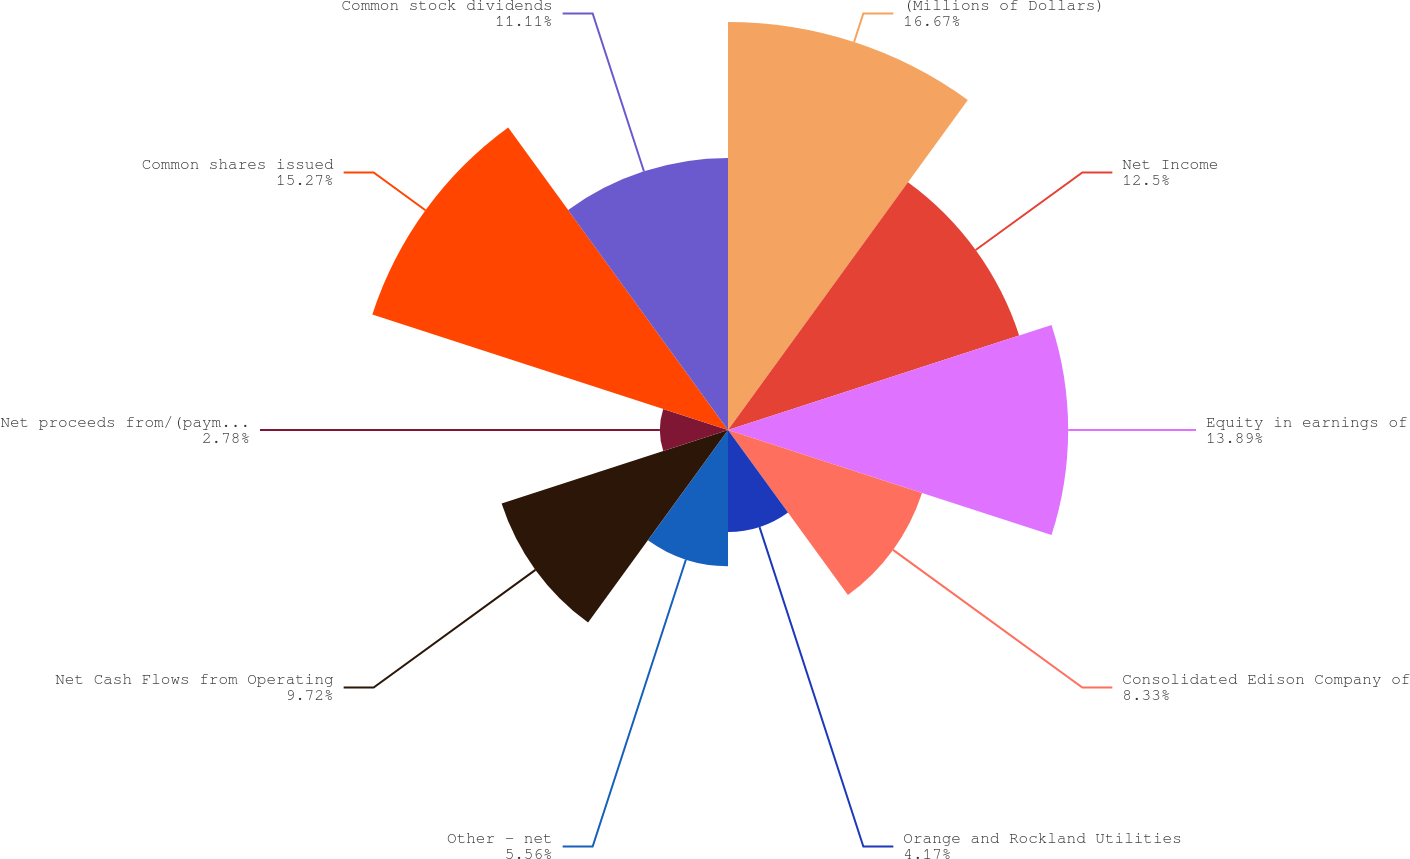Convert chart to OTSL. <chart><loc_0><loc_0><loc_500><loc_500><pie_chart><fcel>(Millions of Dollars)<fcel>Net Income<fcel>Equity in earnings of<fcel>Consolidated Edison Company of<fcel>Orange and Rockland Utilities<fcel>Other - net<fcel>Net Cash Flows from Operating<fcel>Net proceeds from/(payments<fcel>Common shares issued<fcel>Common stock dividends<nl><fcel>16.66%<fcel>12.5%<fcel>13.89%<fcel>8.33%<fcel>4.17%<fcel>5.56%<fcel>9.72%<fcel>2.78%<fcel>15.27%<fcel>11.11%<nl></chart> 